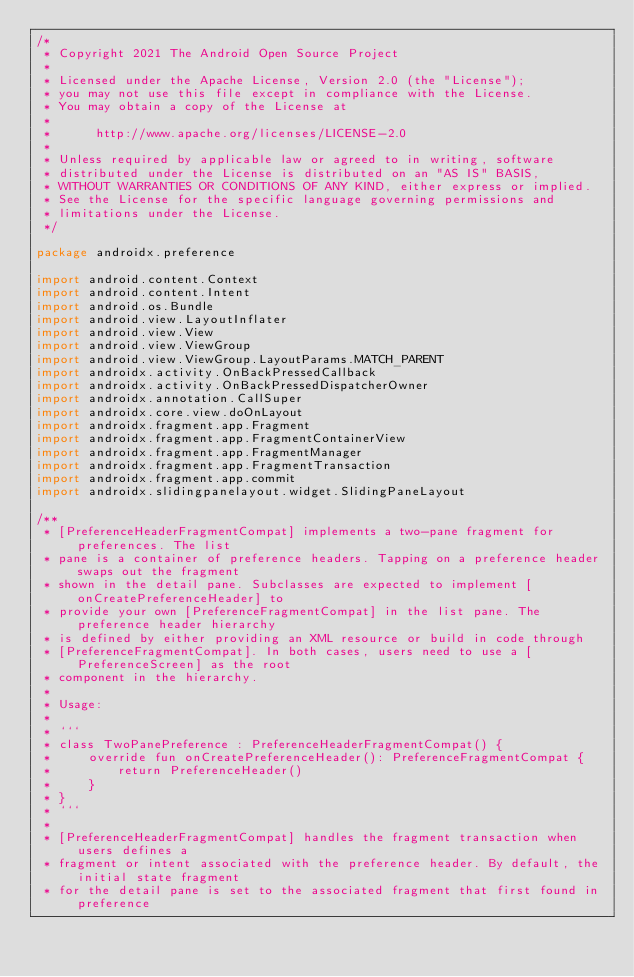<code> <loc_0><loc_0><loc_500><loc_500><_Kotlin_>/*
 * Copyright 2021 The Android Open Source Project
 *
 * Licensed under the Apache License, Version 2.0 (the "License");
 * you may not use this file except in compliance with the License.
 * You may obtain a copy of the License at
 *
 *      http://www.apache.org/licenses/LICENSE-2.0
 *
 * Unless required by applicable law or agreed to in writing, software
 * distributed under the License is distributed on an "AS IS" BASIS,
 * WITHOUT WARRANTIES OR CONDITIONS OF ANY KIND, either express or implied.
 * See the License for the specific language governing permissions and
 * limitations under the License.
 */

package androidx.preference

import android.content.Context
import android.content.Intent
import android.os.Bundle
import android.view.LayoutInflater
import android.view.View
import android.view.ViewGroup
import android.view.ViewGroup.LayoutParams.MATCH_PARENT
import androidx.activity.OnBackPressedCallback
import androidx.activity.OnBackPressedDispatcherOwner
import androidx.annotation.CallSuper
import androidx.core.view.doOnLayout
import androidx.fragment.app.Fragment
import androidx.fragment.app.FragmentContainerView
import androidx.fragment.app.FragmentManager
import androidx.fragment.app.FragmentTransaction
import androidx.fragment.app.commit
import androidx.slidingpanelayout.widget.SlidingPaneLayout

/**
 * [PreferenceHeaderFragmentCompat] implements a two-pane fragment for preferences. The list
 * pane is a container of preference headers. Tapping on a preference header swaps out the fragment
 * shown in the detail pane. Subclasses are expected to implement [onCreatePreferenceHeader] to
 * provide your own [PreferenceFragmentCompat] in the list pane. The preference header hierarchy
 * is defined by either providing an XML resource or build in code through
 * [PreferenceFragmentCompat]. In both cases, users need to use a [PreferenceScreen] as the root
 * component in the hierarchy.
 *
 * Usage:
 *
 * ```
 * class TwoPanePreference : PreferenceHeaderFragmentCompat() {
 *     override fun onCreatePreferenceHeader(): PreferenceFragmentCompat {
 *         return PreferenceHeader()
 *     }
 * }
 * ```
 *
 * [PreferenceHeaderFragmentCompat] handles the fragment transaction when users defines a
 * fragment or intent associated with the preference header. By default, the initial state fragment
 * for the detail pane is set to the associated fragment that first found in preference</code> 